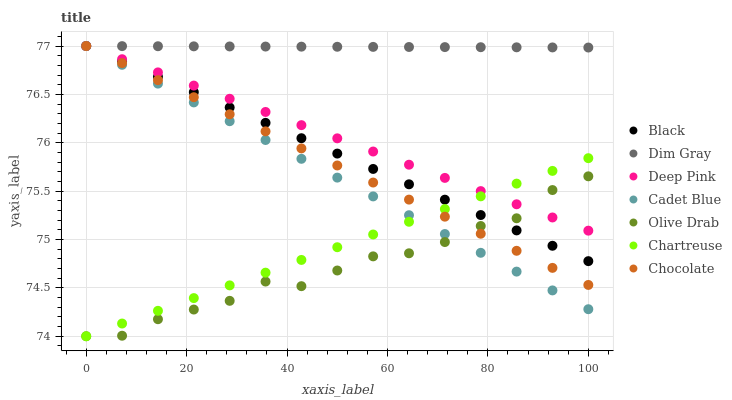Does Olive Drab have the minimum area under the curve?
Answer yes or no. Yes. Does Dim Gray have the maximum area under the curve?
Answer yes or no. Yes. Does Deep Pink have the minimum area under the curve?
Answer yes or no. No. Does Deep Pink have the maximum area under the curve?
Answer yes or no. No. Is Dim Gray the smoothest?
Answer yes or no. Yes. Is Olive Drab the roughest?
Answer yes or no. Yes. Is Deep Pink the smoothest?
Answer yes or no. No. Is Deep Pink the roughest?
Answer yes or no. No. Does Chartreuse have the lowest value?
Answer yes or no. Yes. Does Deep Pink have the lowest value?
Answer yes or no. No. Does Black have the highest value?
Answer yes or no. Yes. Does Chartreuse have the highest value?
Answer yes or no. No. Is Chartreuse less than Dim Gray?
Answer yes or no. Yes. Is Dim Gray greater than Olive Drab?
Answer yes or no. Yes. Does Black intersect Chocolate?
Answer yes or no. Yes. Is Black less than Chocolate?
Answer yes or no. No. Is Black greater than Chocolate?
Answer yes or no. No. Does Chartreuse intersect Dim Gray?
Answer yes or no. No. 